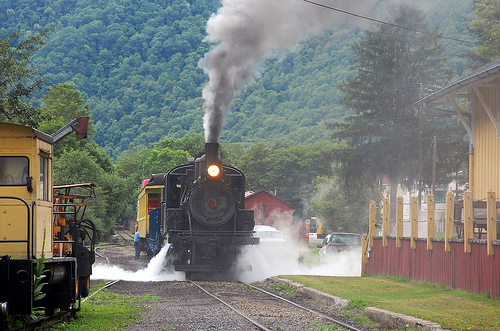<image>
Is there a steam next to the ground? No. The steam is not positioned next to the ground. They are located in different areas of the scene. Is there a steam in front of the train? Yes. The steam is positioned in front of the train, appearing closer to the camera viewpoint. 